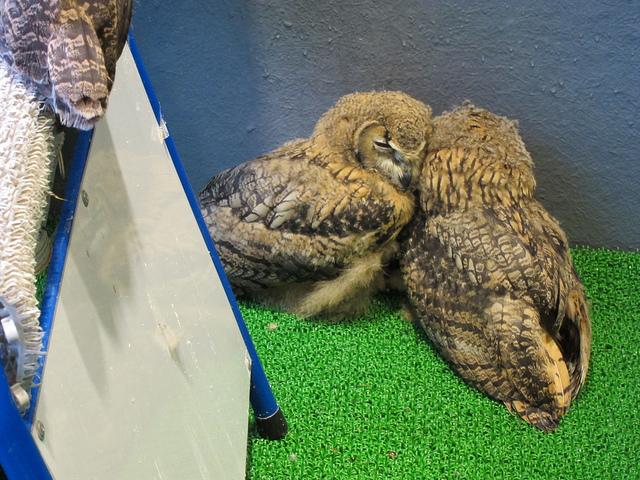When do these animals sleep?
Give a very brief answer. Day. What type of birds are these?
Give a very brief answer. Owls. Are these birds in the wild?
Give a very brief answer. No. 